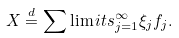Convert formula to latex. <formula><loc_0><loc_0><loc_500><loc_500>X \stackrel { d } { = } \sum \lim i t s ^ { \infty } _ { j = 1 } \xi _ { j } f _ { j } .</formula> 